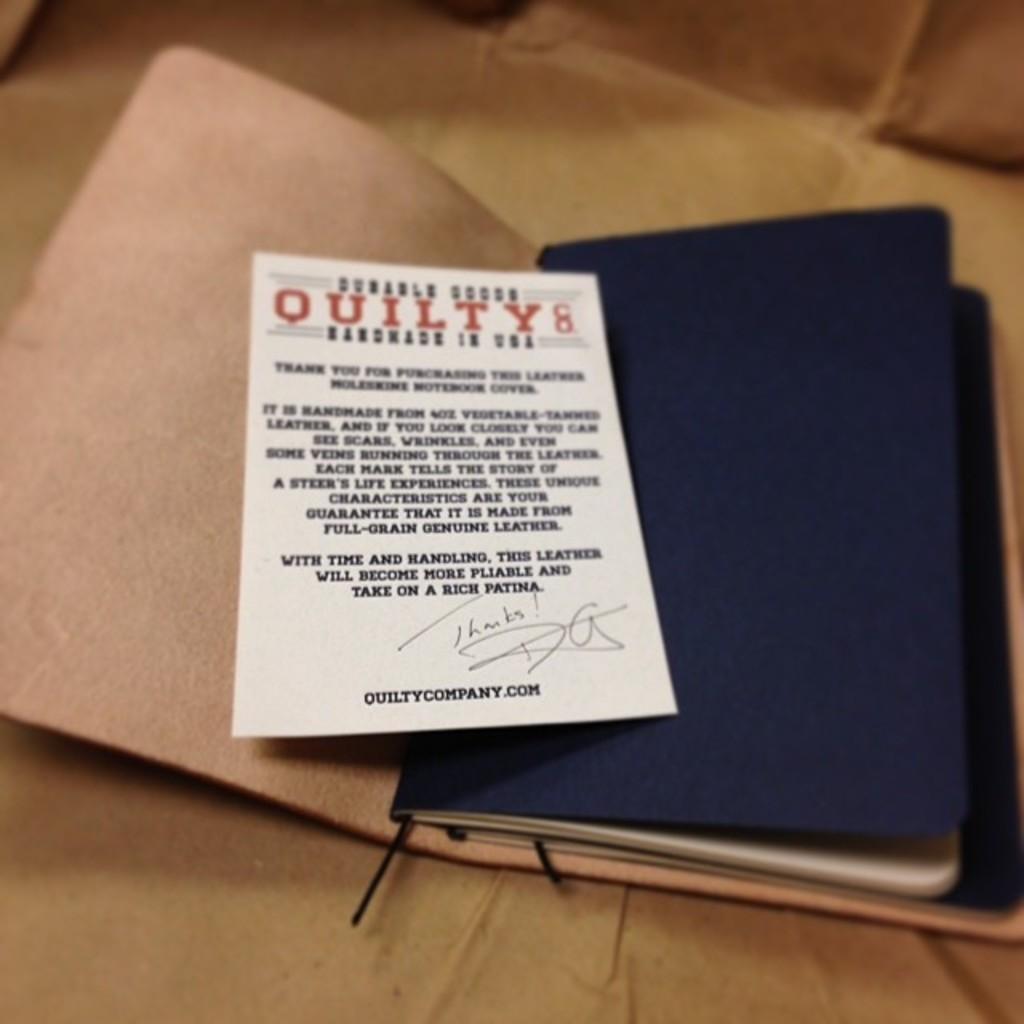What does the red text at the top say?
Offer a very short reply. Quilty. What is the website at the bottom?
Make the answer very short. Quiltycompany.com. 